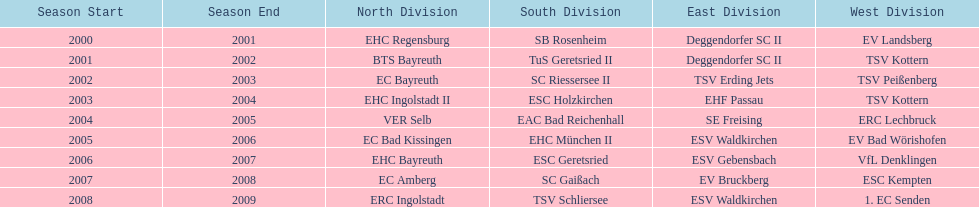What is the number of times deggendorfer sc ii is on the list? 2. 